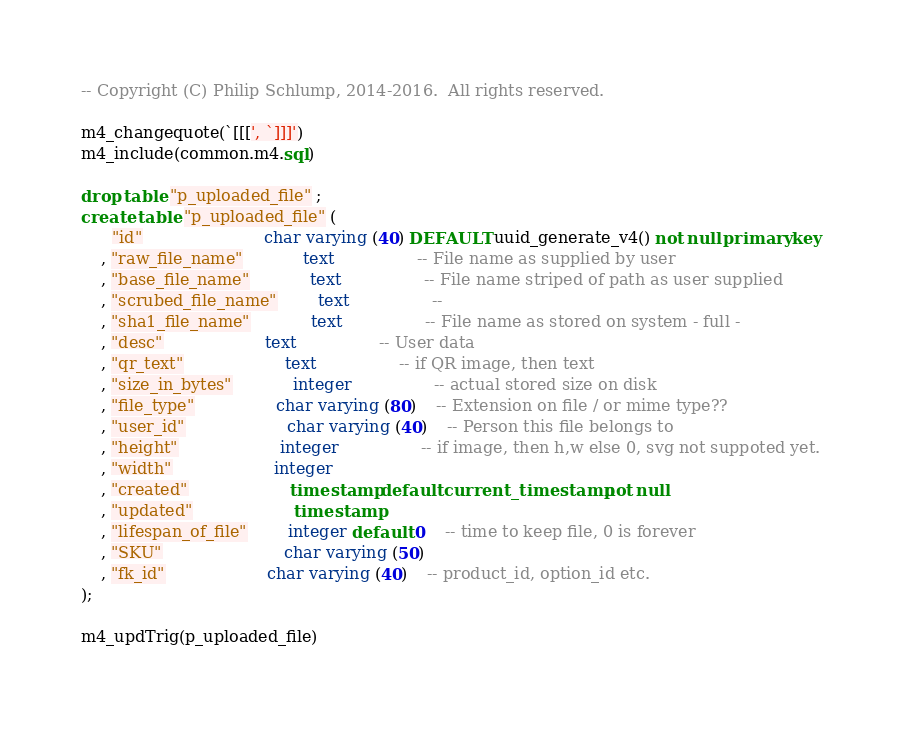<code> <loc_0><loc_0><loc_500><loc_500><_SQL_>

-- Copyright (C) Philip Schlump, 2014-2016.  All rights reserved.

m4_changequote(`[[[', `]]]')
m4_include(common.m4.sql)

drop table "p_uploaded_file" ;
create table "p_uploaded_file" (
	  "id"						char varying (40) DEFAULT uuid_generate_v4() not null primary key
	, "raw_file_name"			text				-- File name as supplied by user
	, "base_file_name"			text				-- File name striped of path as user supplied
	, "scrubed_file_name"		text				-- 
	, "sha1_file_name"			text				-- File name as stored on system - full -
	, "desc"					text				-- User data
	, "qr_text"					text				-- if QR image, then text
	, "size_in_bytes"			integer				-- actual stored size on disk
	, "file_type"				char varying (80) 	-- Extension on file / or mime type??
	, "user_id"					char varying (40) 	-- Person this file belongs to
	, "height"					integer				-- if image, then h,w else 0, svg not suppoted yet.
	, "width"					integer
	, "created"					timestamp default current_timestamp not null
	, "updated"					timestamp
	, "lifespan_of_file"		integer default 0	-- time to keep file, 0 is forever
	, "SKU"						char varying (50)
	, "fk_id"					char varying (40) 	-- product_id, option_id etc.
);

m4_updTrig(p_uploaded_file)

</code> 